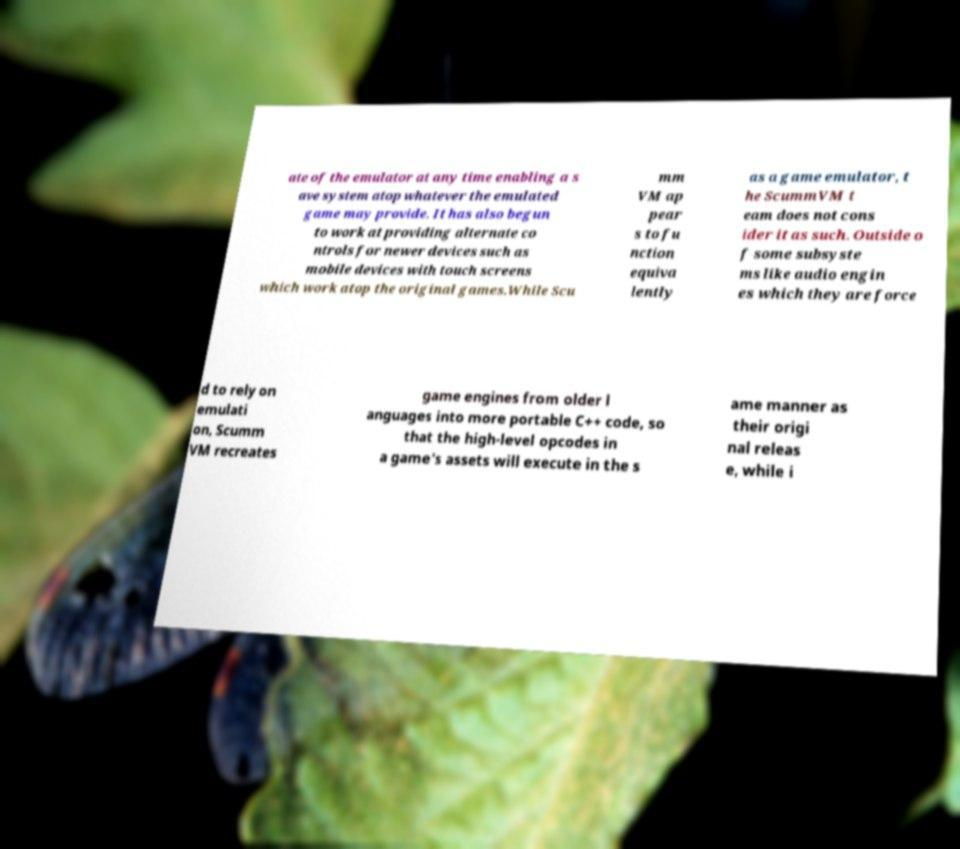I need the written content from this picture converted into text. Can you do that? ate of the emulator at any time enabling a s ave system atop whatever the emulated game may provide. It has also begun to work at providing alternate co ntrols for newer devices such as mobile devices with touch screens which work atop the original games.While Scu mm VM ap pear s to fu nction equiva lently as a game emulator, t he ScummVM t eam does not cons ider it as such. Outside o f some subsyste ms like audio engin es which they are force d to rely on emulati on, Scumm VM recreates game engines from older l anguages into more portable C++ code, so that the high-level opcodes in a game's assets will execute in the s ame manner as their origi nal releas e, while i 